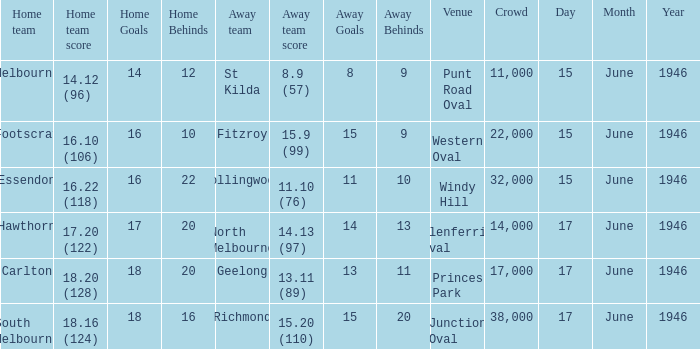On what date was a game played at Windy Hill? 15 June 1946. 